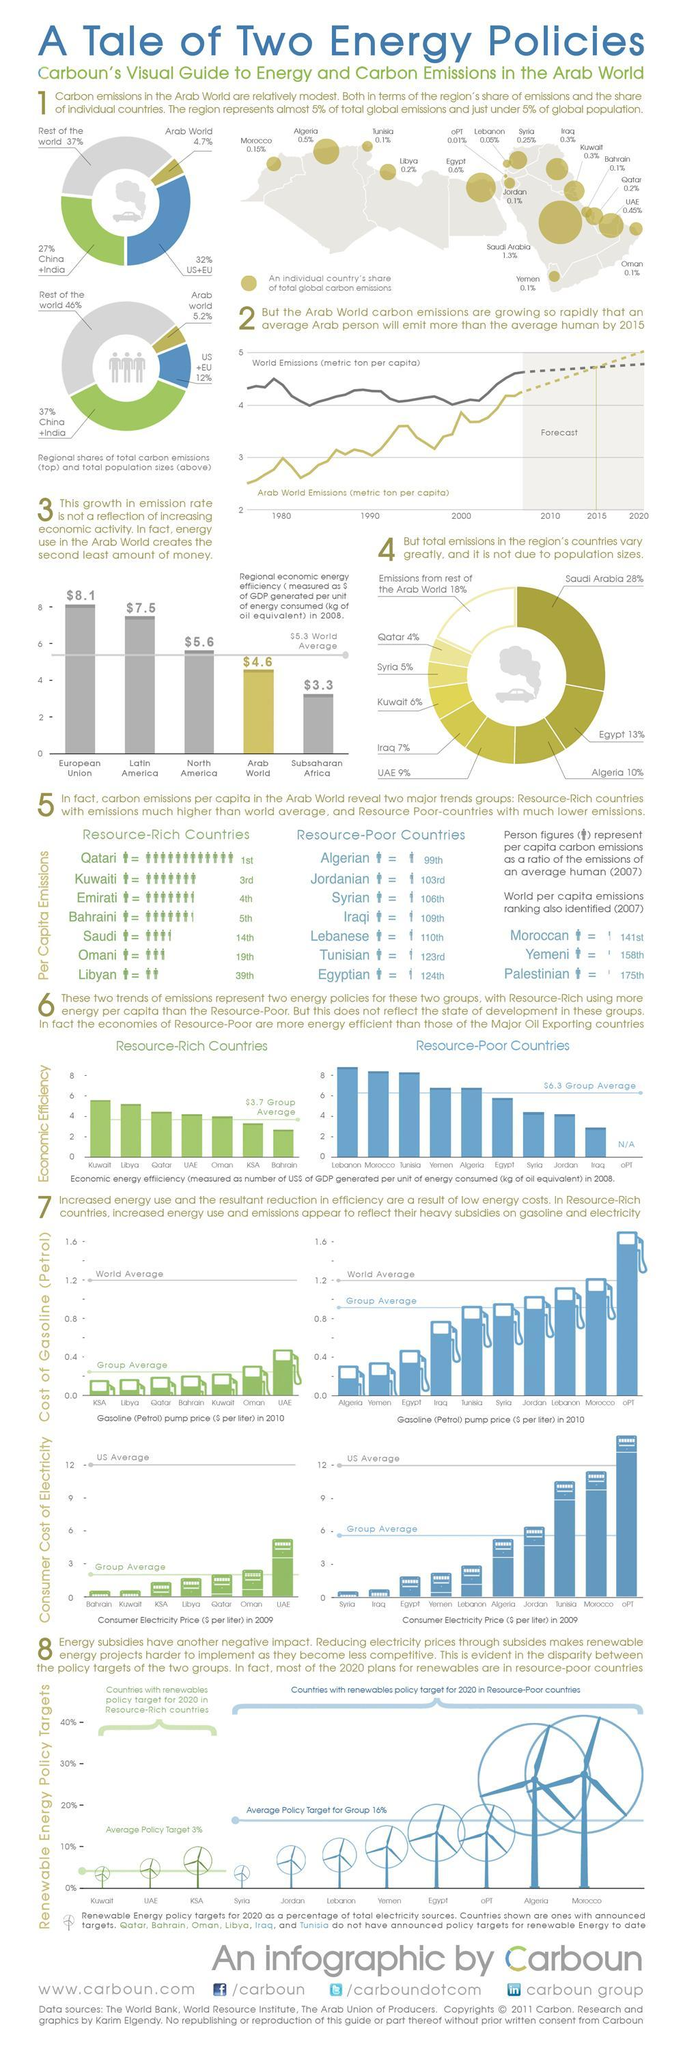Which Arab country has the second-highest amount of global carbon emission?
Answer the question with a short phrase. Egypt What is the color code given to the United States and the European Union in global carbon emissions- yellow, green, blue, red? blue Which Arab country poor in resources have second-highest renewable energy policy target in 2020? Algeria Which Arab country poor in resources have second-highest economic efficiency? Morocco What is the carbon emission rate of the Arab World globally? 4.7% How many Arab countries rich in resources have economic efficiency less than average? 2 Which Arab country rich in resources have second-highest electricity rate? Oman Which Arab country poor in resources have third-highest electricity rate? Tunisia Which Arab country has the highest global carbon emission? Saudi Arabia What is the carbon emission rate of China and India globally? 27% 